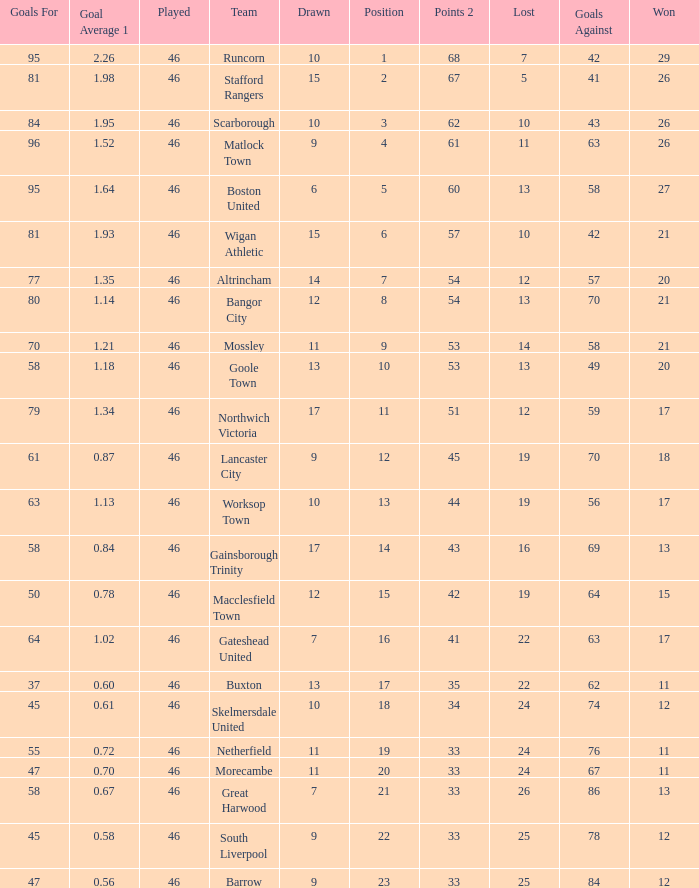Which team had goal averages of 1.34? Northwich Victoria. 